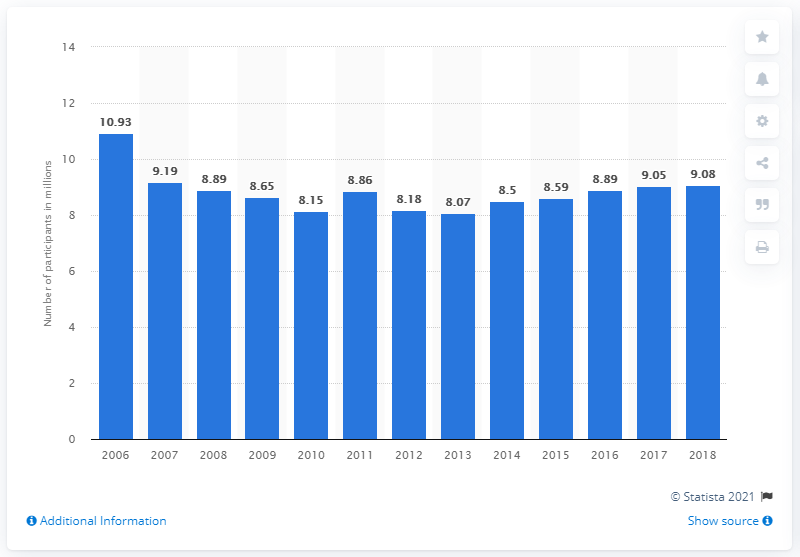List a handful of essential elements in this visual. There were 9,080 participants in Pilates training in 2018. 